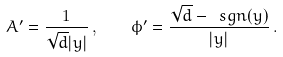Convert formula to latex. <formula><loc_0><loc_0><loc_500><loc_500>A ^ { \prime } = \frac { 1 } { \sqrt { d } | y | } \, , \quad \phi ^ { \prime } = \frac { \sqrt { d } - \ s g n ( y ) } { | y | } \, .</formula> 